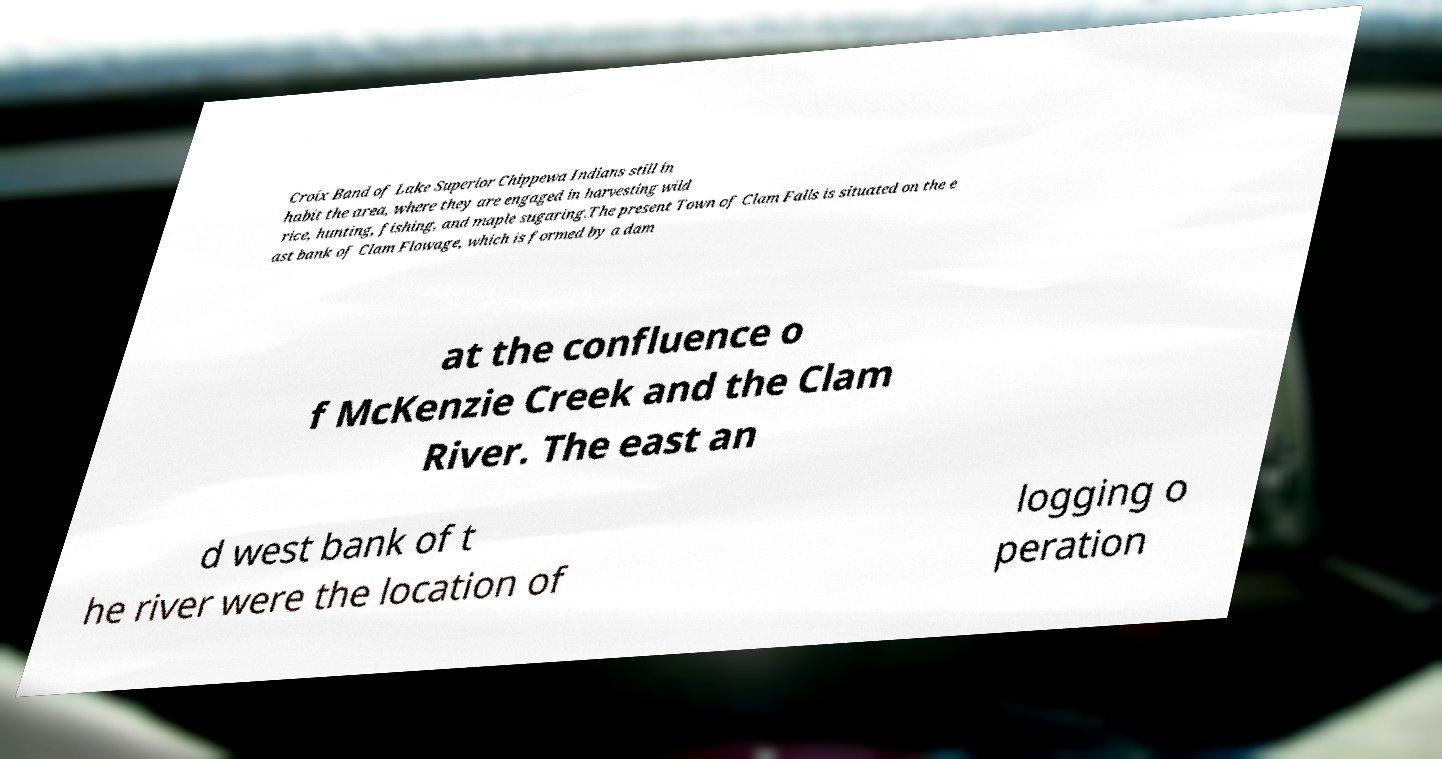For documentation purposes, I need the text within this image transcribed. Could you provide that? Croix Band of Lake Superior Chippewa Indians still in habit the area, where they are engaged in harvesting wild rice, hunting, fishing, and maple sugaring.The present Town of Clam Falls is situated on the e ast bank of Clam Flowage, which is formed by a dam at the confluence o f McKenzie Creek and the Clam River. The east an d west bank of t he river were the location of logging o peration 